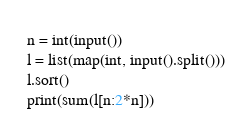<code> <loc_0><loc_0><loc_500><loc_500><_Python_>n = int(input())
l = list(map(int, input().split()))
l.sort()
print(sum(l[n:2*n]))</code> 